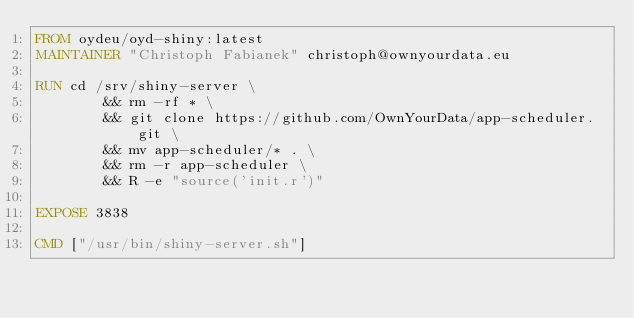Convert code to text. <code><loc_0><loc_0><loc_500><loc_500><_Dockerfile_>FROM oydeu/oyd-shiny:latest
MAINTAINER "Christoph Fabianek" christoph@ownyourdata.eu

RUN cd /srv/shiny-server \
        && rm -rf * \
        && git clone https://github.com/OwnYourData/app-scheduler.git \ 
        && mv app-scheduler/* . \
        && rm -r app-scheduler \
        && R -e "source('init.r')"

EXPOSE 3838

CMD ["/usr/bin/shiny-server.sh"]
</code> 